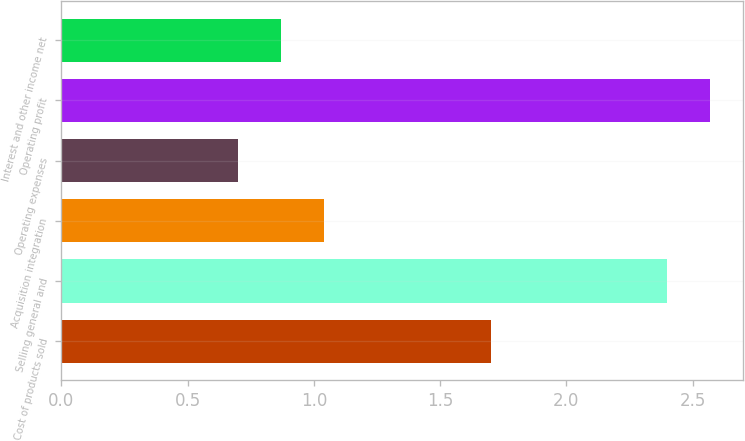Convert chart to OTSL. <chart><loc_0><loc_0><loc_500><loc_500><bar_chart><fcel>Cost of products sold<fcel>Selling general and<fcel>Acquisition integration<fcel>Operating expenses<fcel>Operating profit<fcel>Interest and other income net<nl><fcel>1.7<fcel>2.4<fcel>1.04<fcel>0.7<fcel>2.57<fcel>0.87<nl></chart> 